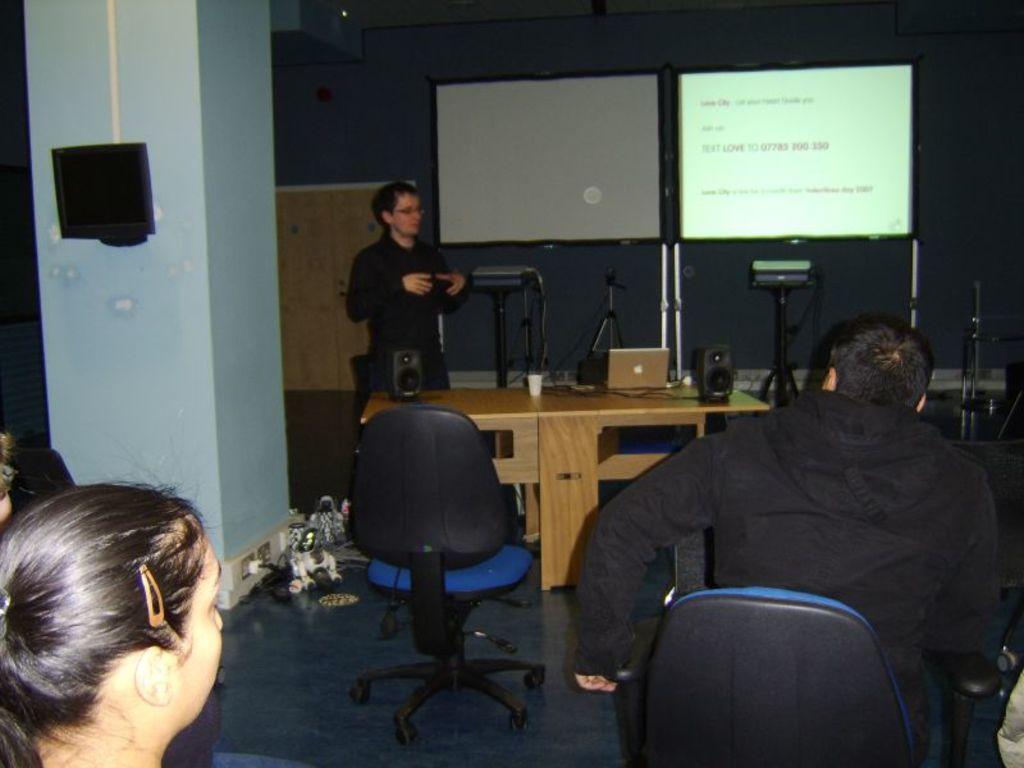How would you summarize this image in a sentence or two? In this picture there is a man standing and talking and there is a laptop and cup and there are speakers on the table. At the back there are screens and there are devices and objects. In the foreground there are three people sitting and there are chairs and there is a screen and pipe on the wall. At the bottom there are objects on the floor. 